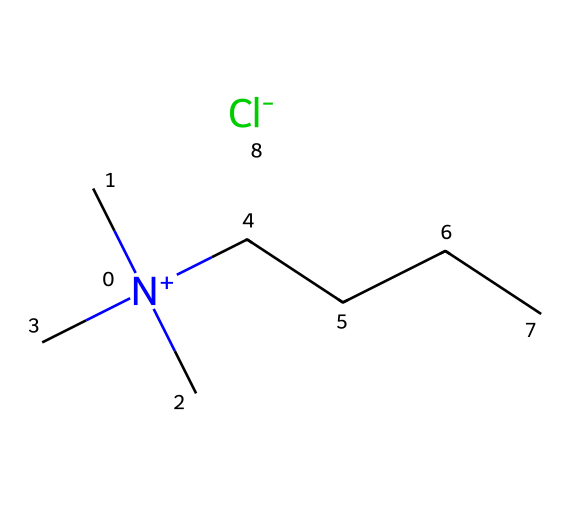What is the total number of carbon atoms in this ionic liquid? By analyzing the SMILES representation, we can identify that there are three methyl groups represented by the three (C) characters attached to the nitrogen atom, and there is a straight-chain carbon component indicated by "CCCC", which contains four carbon atoms. Therefore, the total number of carbon atoms is 3 (from methyl groups) + 4 (from the chain) = 7.
Answer: 7 What type of ion is represented by [Cl-]? In the SMILES notation, [Cl-] indicates a chlorine ion with a negative charge. This is identified by the notation within square brackets, which denotes the ion, and the negative sign indicating its charge.
Answer: chloride ion How many nitrogen atoms are present in the structure? The SMILES representation shows [N+] which indicates one nitrogen atom that carries a positive charge. There are no other occurrences of nitrogen in the structure. Hence, there is only one nitrogen atom present.
Answer: 1 What charge does the nitrogen atom have? In the provided SMILES, the nitrogen is represented as [N+], signifying that it carries a positive charge based on the notation seen in the brackets. The "+" sign explicitly denotes this positive state.
Answer: positive What kind of chemical structure is indicated by the presence of a long carbon chain in this ionic liquid? The long carbon chain represented by "CCCC" in the SMILES shows that this ionic liquid contains a hydrophobic structure, which is characteristic of ionic liquids designed for solvation or preservation, as it typically enhances solubility with organic compounds like ancient manuscripts.
Answer: hydrophobic structure What is the significance of having both cationic and anionic components in ionic liquids like this one? The presence of both cations and anions, such as the N+ cation and Cl- anion here, enables ionic liquids to exhibit low volatility and tunable properties, which are advantageous for various applications including preservation of delicate materials like manuscripts.
Answer: tunable properties 